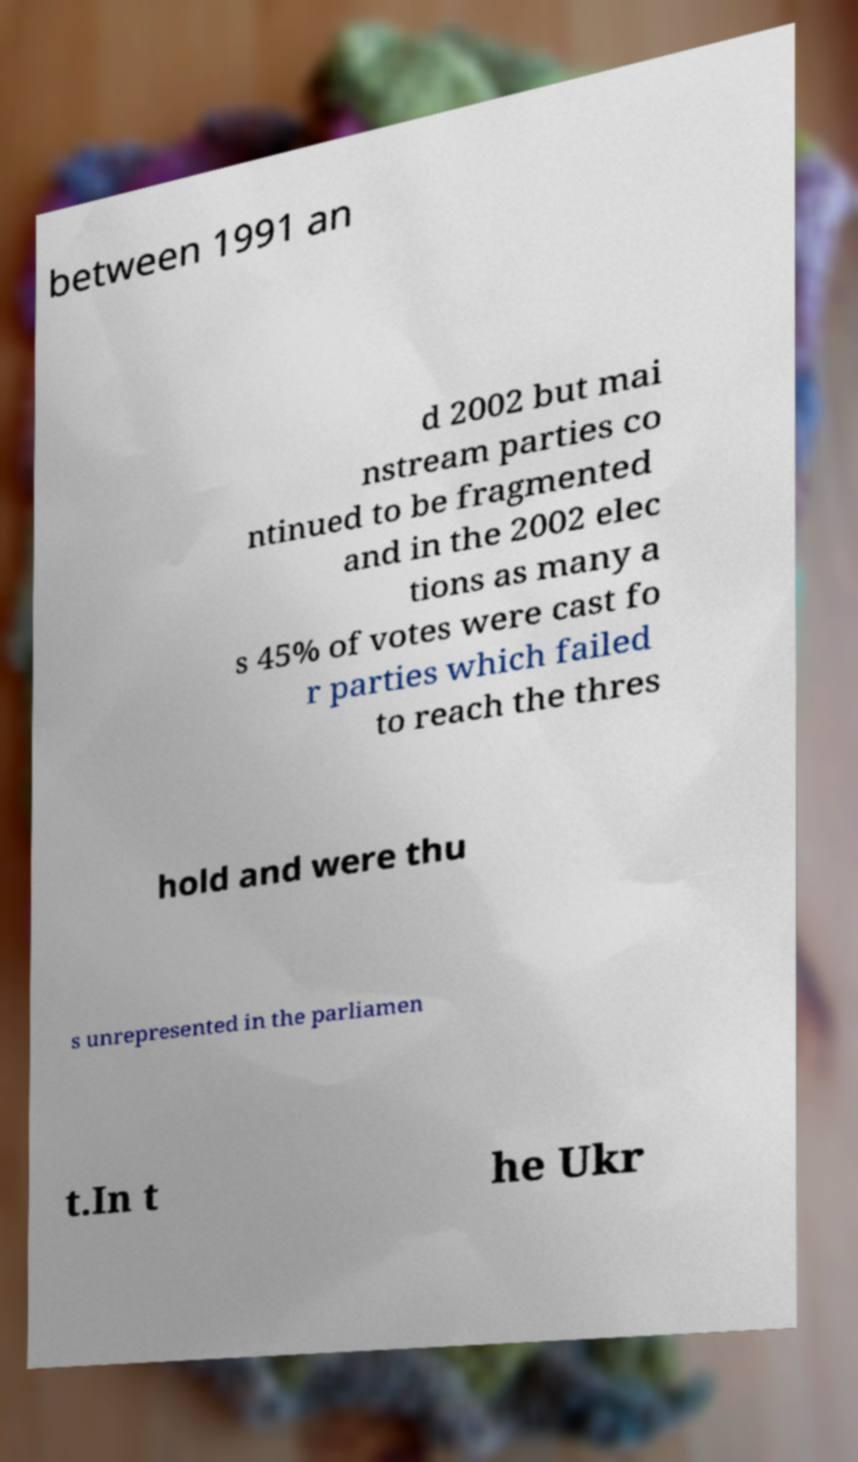What messages or text are displayed in this image? I need them in a readable, typed format. between 1991 an d 2002 but mai nstream parties co ntinued to be fragmented and in the 2002 elec tions as many a s 45% of votes were cast fo r parties which failed to reach the thres hold and were thu s unrepresented in the parliamen t.In t he Ukr 